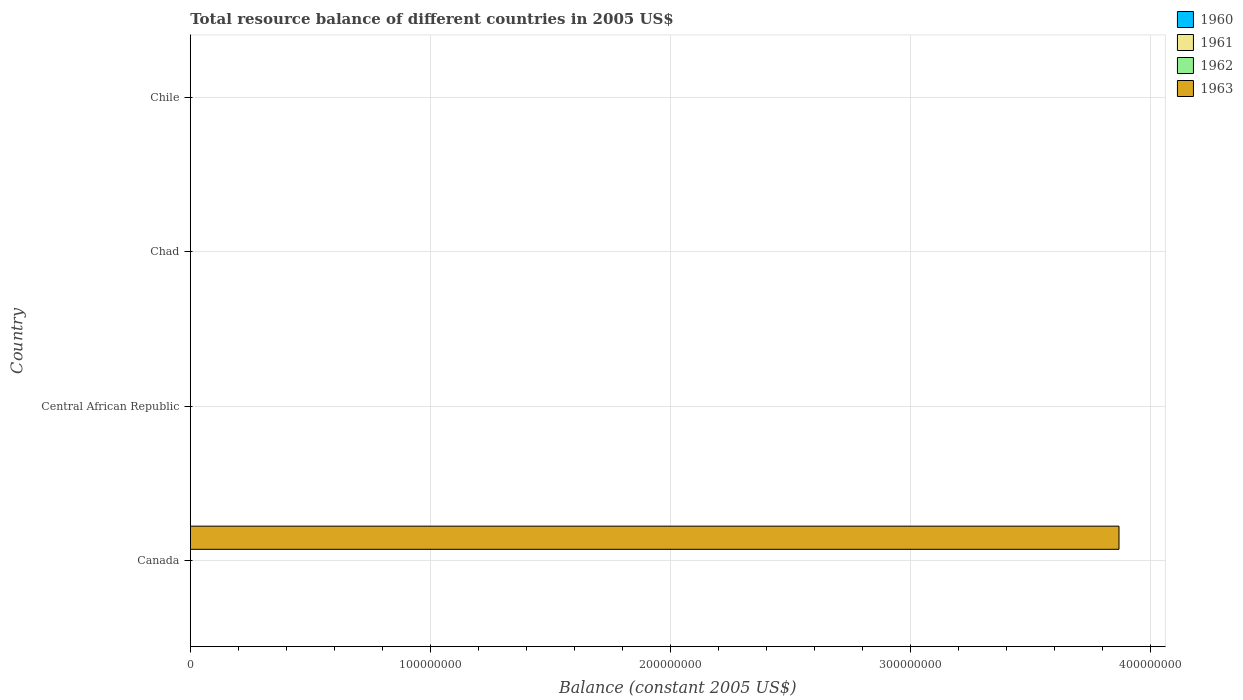How many different coloured bars are there?
Your response must be concise. 1. Are the number of bars per tick equal to the number of legend labels?
Provide a short and direct response. No. How many bars are there on the 4th tick from the top?
Your response must be concise. 1. What is the label of the 4th group of bars from the top?
Provide a short and direct response. Canada. What is the total resource balance in 1962 in Chile?
Your answer should be very brief. 0. In which country was the total resource balance in 1963 maximum?
Make the answer very short. Canada. What is the average total resource balance in 1960 per country?
Offer a terse response. 0. In how many countries, is the total resource balance in 1960 greater than the average total resource balance in 1960 taken over all countries?
Offer a terse response. 0. Is it the case that in every country, the sum of the total resource balance in 1960 and total resource balance in 1962 is greater than the total resource balance in 1963?
Give a very brief answer. No. How many bars are there?
Your answer should be compact. 1. Are the values on the major ticks of X-axis written in scientific E-notation?
Provide a succinct answer. No. Does the graph contain any zero values?
Offer a very short reply. Yes. What is the title of the graph?
Ensure brevity in your answer.  Total resource balance of different countries in 2005 US$. Does "1974" appear as one of the legend labels in the graph?
Give a very brief answer. No. What is the label or title of the X-axis?
Your response must be concise. Balance (constant 2005 US$). What is the label or title of the Y-axis?
Provide a short and direct response. Country. What is the Balance (constant 2005 US$) in 1963 in Canada?
Offer a very short reply. 3.87e+08. What is the Balance (constant 2005 US$) in 1961 in Central African Republic?
Make the answer very short. 0. What is the Balance (constant 2005 US$) in 1962 in Central African Republic?
Offer a terse response. 0. What is the Balance (constant 2005 US$) of 1963 in Chad?
Offer a terse response. 0. What is the Balance (constant 2005 US$) of 1960 in Chile?
Provide a succinct answer. 0. What is the Balance (constant 2005 US$) in 1963 in Chile?
Provide a short and direct response. 0. Across all countries, what is the maximum Balance (constant 2005 US$) of 1963?
Your answer should be very brief. 3.87e+08. What is the total Balance (constant 2005 US$) of 1960 in the graph?
Give a very brief answer. 0. What is the total Balance (constant 2005 US$) in 1961 in the graph?
Offer a very short reply. 0. What is the total Balance (constant 2005 US$) of 1963 in the graph?
Provide a short and direct response. 3.87e+08. What is the average Balance (constant 2005 US$) of 1961 per country?
Your answer should be compact. 0. What is the average Balance (constant 2005 US$) in 1963 per country?
Make the answer very short. 9.68e+07. What is the difference between the highest and the lowest Balance (constant 2005 US$) of 1963?
Offer a very short reply. 3.87e+08. 